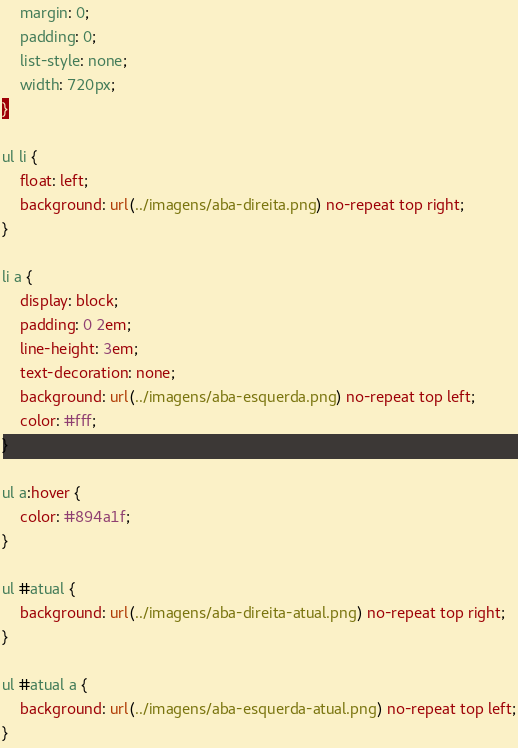Convert code to text. <code><loc_0><loc_0><loc_500><loc_500><_CSS_>	margin: 0;
	padding: 0;
	list-style: none;
	width: 720px;
}

ul li {
	float: left;
	background: url(../imagens/aba-direita.png) no-repeat top right;
}

li a {
	display: block;
	padding: 0 2em;
	line-height: 3em;
	text-decoration: none;
	background: url(../imagens/aba-esquerda.png) no-repeat top left;
	color: #fff;
}

ul a:hover {
	color: #894a1f;
}

ul #atual {
	background: url(../imagens/aba-direita-atual.png) no-repeat top right;
}

ul #atual a {
	background: url(../imagens/aba-esquerda-atual.png) no-repeat top left;
}</code> 